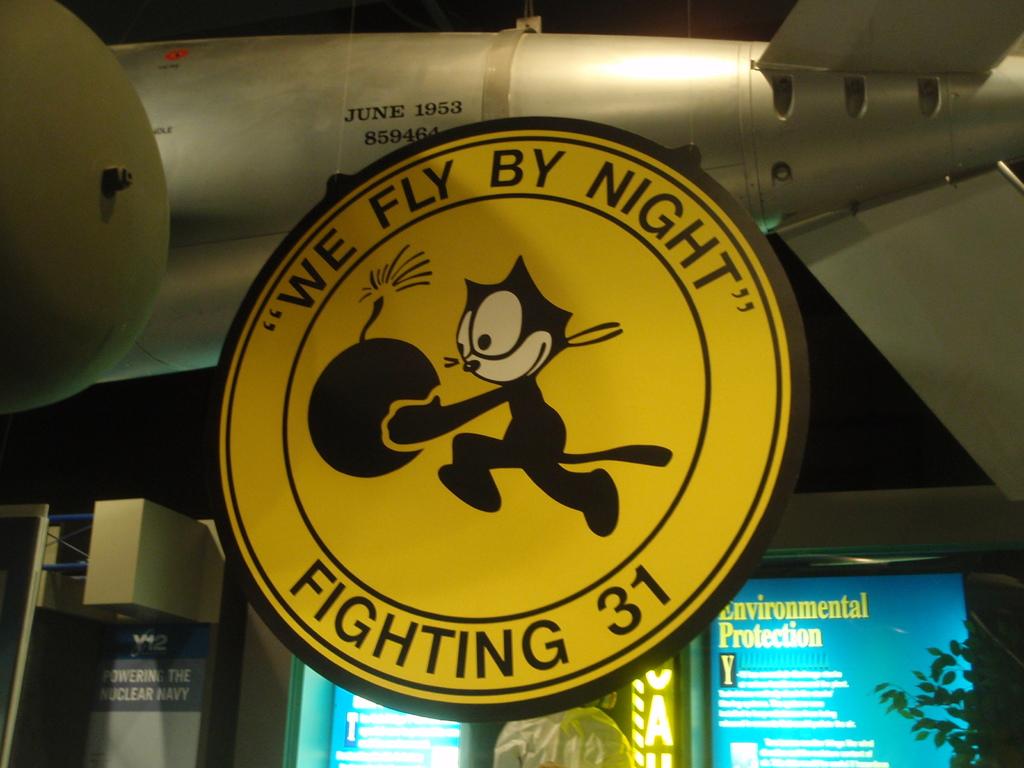What does the yellow sign say?
Provide a succinct answer. We fly by night. 